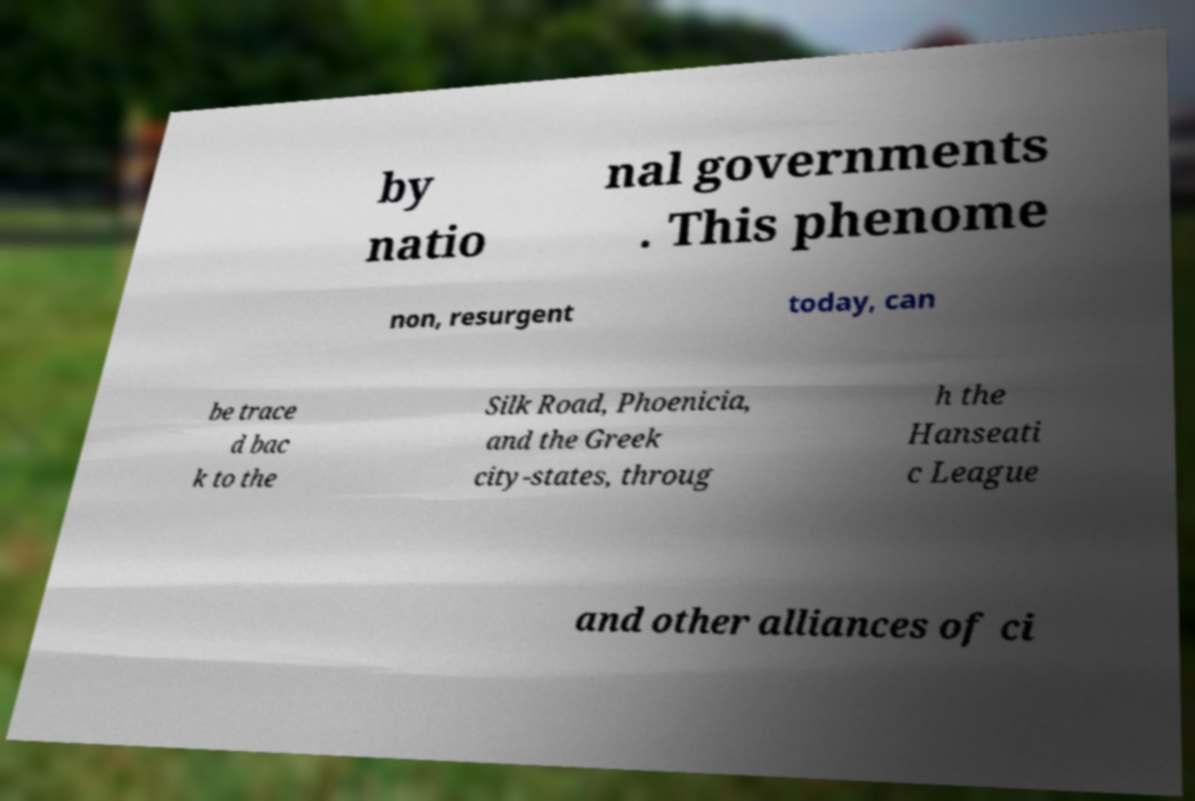What messages or text are displayed in this image? I need them in a readable, typed format. by natio nal governments . This phenome non, resurgent today, can be trace d bac k to the Silk Road, Phoenicia, and the Greek city-states, throug h the Hanseati c League and other alliances of ci 